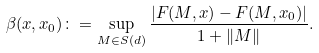Convert formula to latex. <formula><loc_0><loc_0><loc_500><loc_500>\beta ( x , x _ { 0 } ) \colon = \sup _ { M \in S ( d ) } \frac { | F ( M , x ) - F ( M , x _ { 0 } ) | } { 1 + \| M \| } .</formula> 